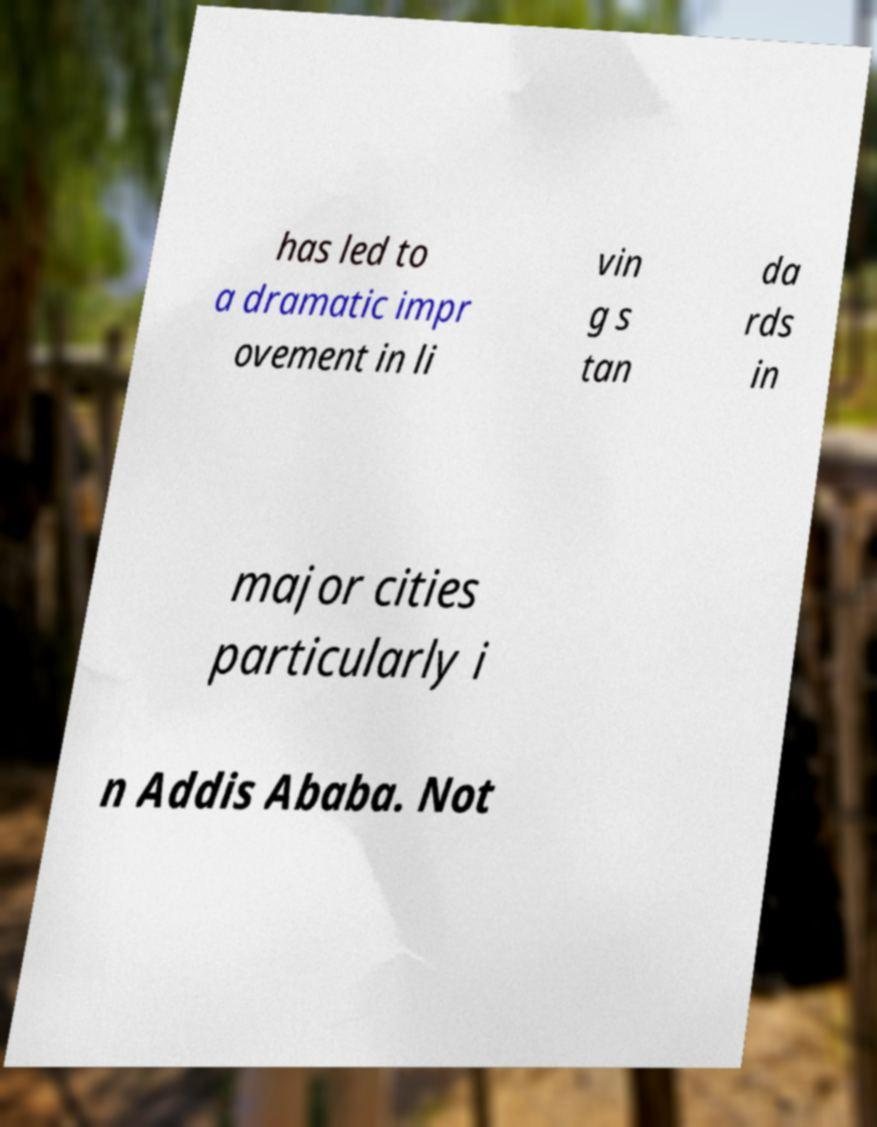Please identify and transcribe the text found in this image. has led to a dramatic impr ovement in li vin g s tan da rds in major cities particularly i n Addis Ababa. Not 